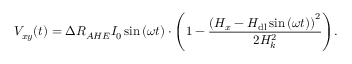Convert formula to latex. <formula><loc_0><loc_0><loc_500><loc_500>V _ { x y } ( t ) = \Delta R _ { A H E } I _ { 0 } \sin { ( \omega t ) } \cdot { \left ( 1 - \frac { \left ( H _ { x } - H _ { d l } \sin { ( \omega t ) } \right ) ^ { 2 } } { 2 H _ { k } ^ { 2 } } \right ) } .</formula> 